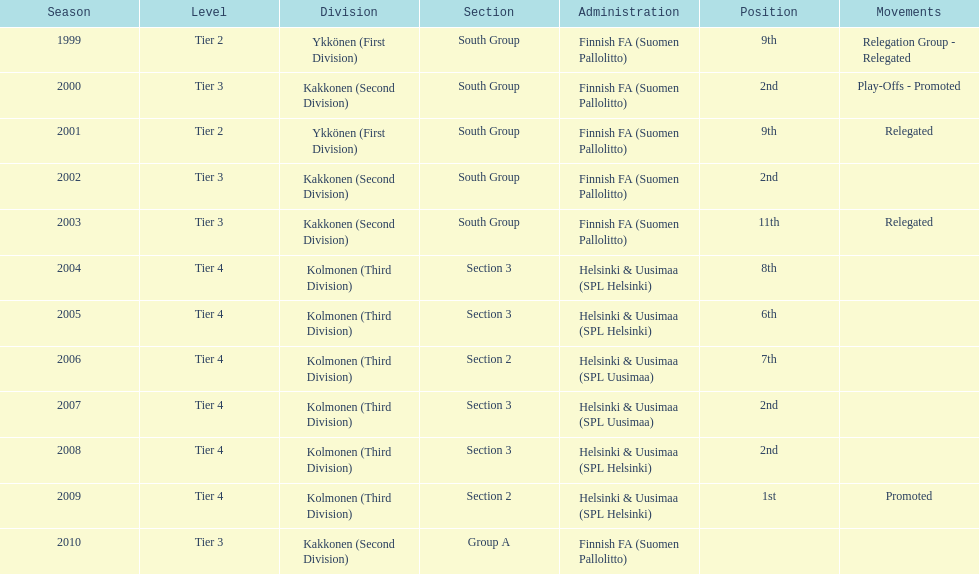How many times has this team been relegated? 3. 